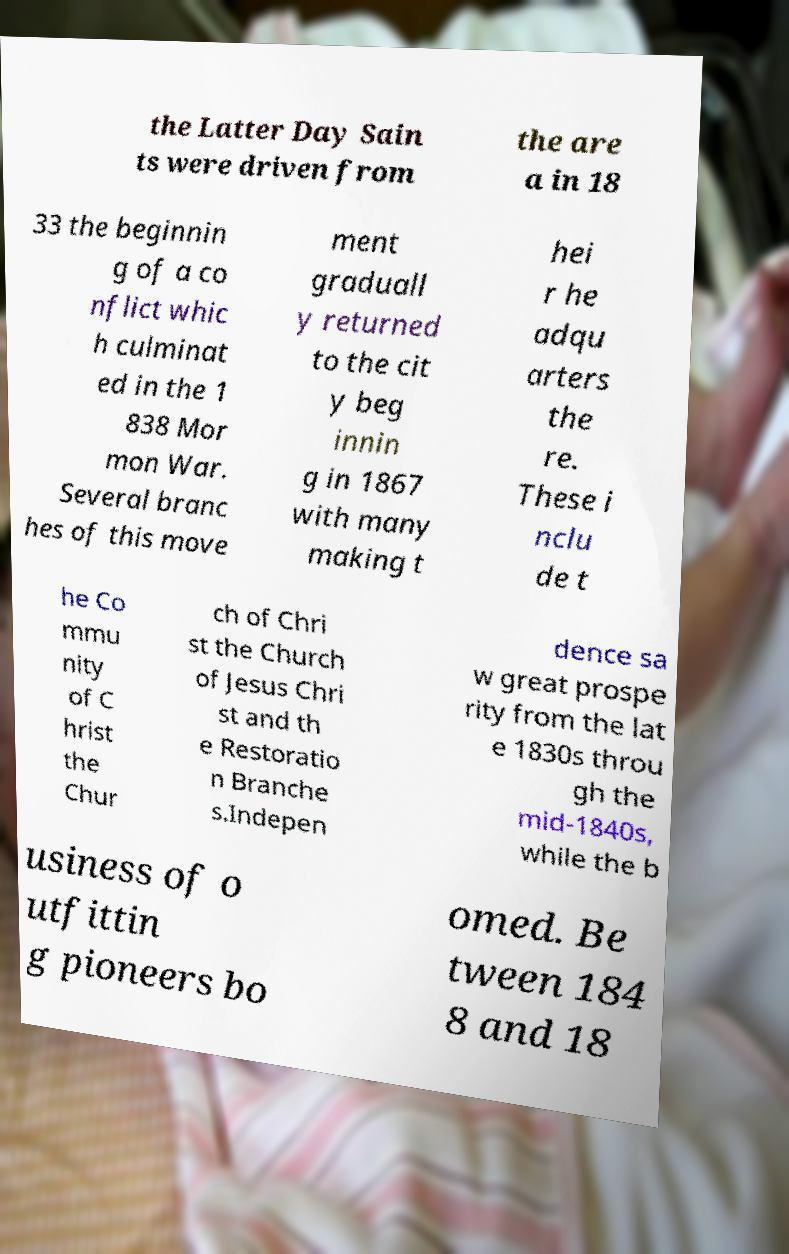For documentation purposes, I need the text within this image transcribed. Could you provide that? the Latter Day Sain ts were driven from the are a in 18 33 the beginnin g of a co nflict whic h culminat ed in the 1 838 Mor mon War. Several branc hes of this move ment graduall y returned to the cit y beg innin g in 1867 with many making t hei r he adqu arters the re. These i nclu de t he Co mmu nity of C hrist the Chur ch of Chri st the Church of Jesus Chri st and th e Restoratio n Branche s.Indepen dence sa w great prospe rity from the lat e 1830s throu gh the mid-1840s, while the b usiness of o utfittin g pioneers bo omed. Be tween 184 8 and 18 